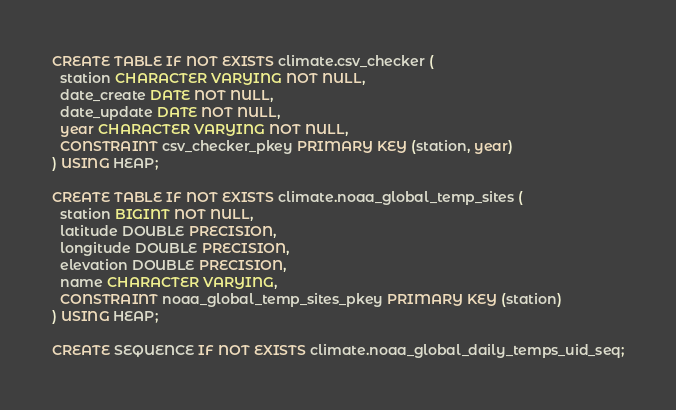<code> <loc_0><loc_0><loc_500><loc_500><_SQL_>CREATE TABLE IF NOT EXISTS climate.csv_checker (
  station CHARACTER VARYING NOT NULL,
  date_create DATE NOT NULL,
  date_update DATE NOT NULL,
  year CHARACTER VARYING NOT NULL,
  CONSTRAINT csv_checker_pkey PRIMARY KEY (station, year)
) USING HEAP;

CREATE TABLE IF NOT EXISTS climate.noaa_global_temp_sites (
  station BIGINT NOT NULL,
  latitude DOUBLE PRECISION,
  longitude DOUBLE PRECISION,
  elevation DOUBLE PRECISION,
  name CHARACTER VARYING,
  CONSTRAINT noaa_global_temp_sites_pkey PRIMARY KEY (station)
) USING HEAP;

CREATE SEQUENCE IF NOT EXISTS climate.noaa_global_daily_temps_uid_seq;
</code> 